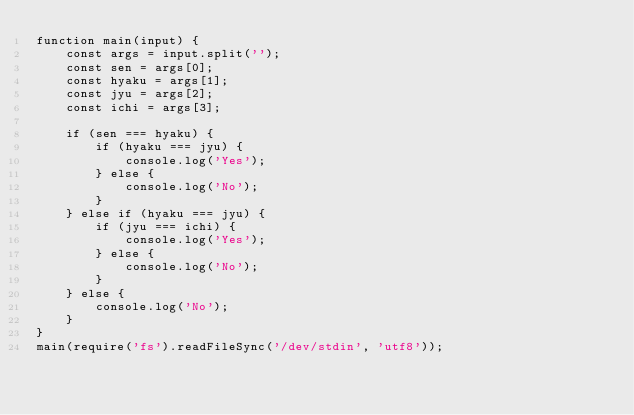<code> <loc_0><loc_0><loc_500><loc_500><_JavaScript_>function main(input) {
    const args = input.split('');
    const sen = args[0];
    const hyaku = args[1];
    const jyu = args[2];
    const ichi = args[3];

    if (sen === hyaku) {
        if (hyaku === jyu) {
            console.log('Yes');
        } else {
            console.log('No');
        }
    } else if (hyaku === jyu) {
        if (jyu === ichi) {
            console.log('Yes');
        } else {
            console.log('No');
        }
    } else {
        console.log('No');
    }
}
main(require('fs').readFileSync('/dev/stdin', 'utf8'));</code> 